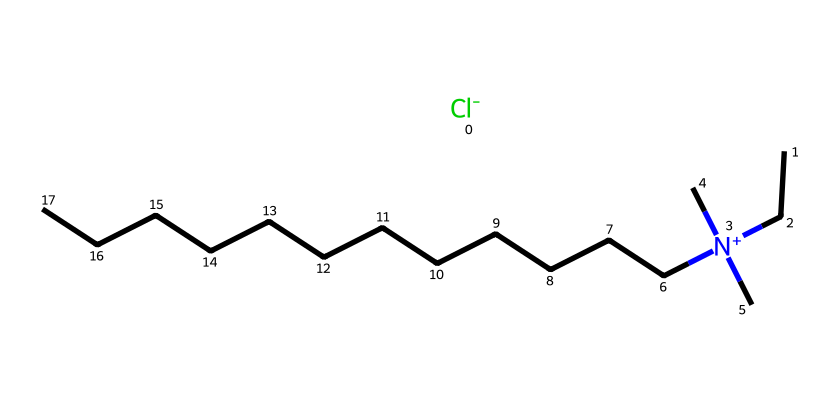What is the total number of carbon atoms in this compound? To determine the total number of carbon atoms, we analyze the SMILES representation. The chain has multiple carbon atoms represented by “C” and includes one nitrogen connected to three carbon branches. Counting each "C" in the chain gives a total of 15 carbon atoms.
Answer: 15 How many nitrogen atoms are present in this chemical structure? From the SMILES representation, we can identify the presence of a nitrogen atom, which is represented by "N". There is only one nitrogen atom connected to two methyl groups and a longer carbon chain.
Answer: 1 What is the overall charge of benzalkonium chloride? The charge of benzalkonium chloride is indicated by the notation “[N+](C)(C)”. The presence of “[N+]” shows that the nitrogen is positively charged, while the “Cl-” shows there is also a negatively charged chloride ion. Together they balance out to give an overall neutral compound.
Answer: neutral What type of compound is this classified as? Benzalkonium chloride is classified as a quaternary ammonium compound. This classification is due to the presence of a positively charged nitrogen atom bonded to four carbon-containing groups, fulfilling the structural definition of quaternary ammonium.
Answer: quaternary ammonium What is the connection between the long carbon chain and its antimicrobial properties? The long hydrophobic carbon chain contributes to the antimicrobial properties by effectively disrupting cell membranes of bacteria. This hydrophobic region allows the molecule to interact with and penetrate lipid bilayers of microbial cells, ultimately leading to cell lysis.
Answer: disrupts cell membranes What role does the chloride ion play in the function of this compound? The chloride ion plays a critical role in stabilizing the quaternary ammonium structure, allowing the molecule to exist in an active form. Additionally, it aids in enhancing the solubility and dispersion of the compound in aqueous solutions, further facilitating its disinfectant properties.
Answer: stabilizing agent 